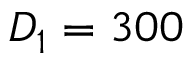<formula> <loc_0><loc_0><loc_500><loc_500>D _ { 1 } = 3 0 0</formula> 